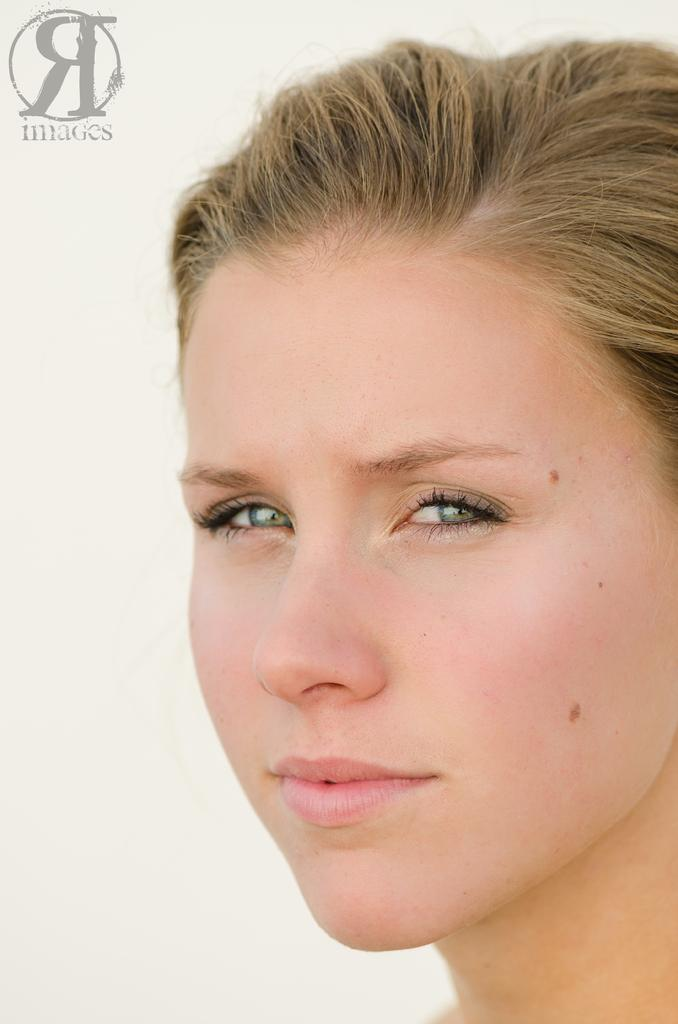Who is present in the image? There is a woman in the image. What is the woman doing in the image? The woman is smiling in the image. Is there any text or logo visible in the image? Yes, there is a watermark at the top left side of the image. What is the color of the background in the image? The background of the image appears to be white in color. What type of guitar is the woman playing in the image? There is no guitar present in the image; the woman is simply smiling. Can you see the woman's thumb in the image? The image does not show the woman's thumb, as it focuses on her face and smile. 